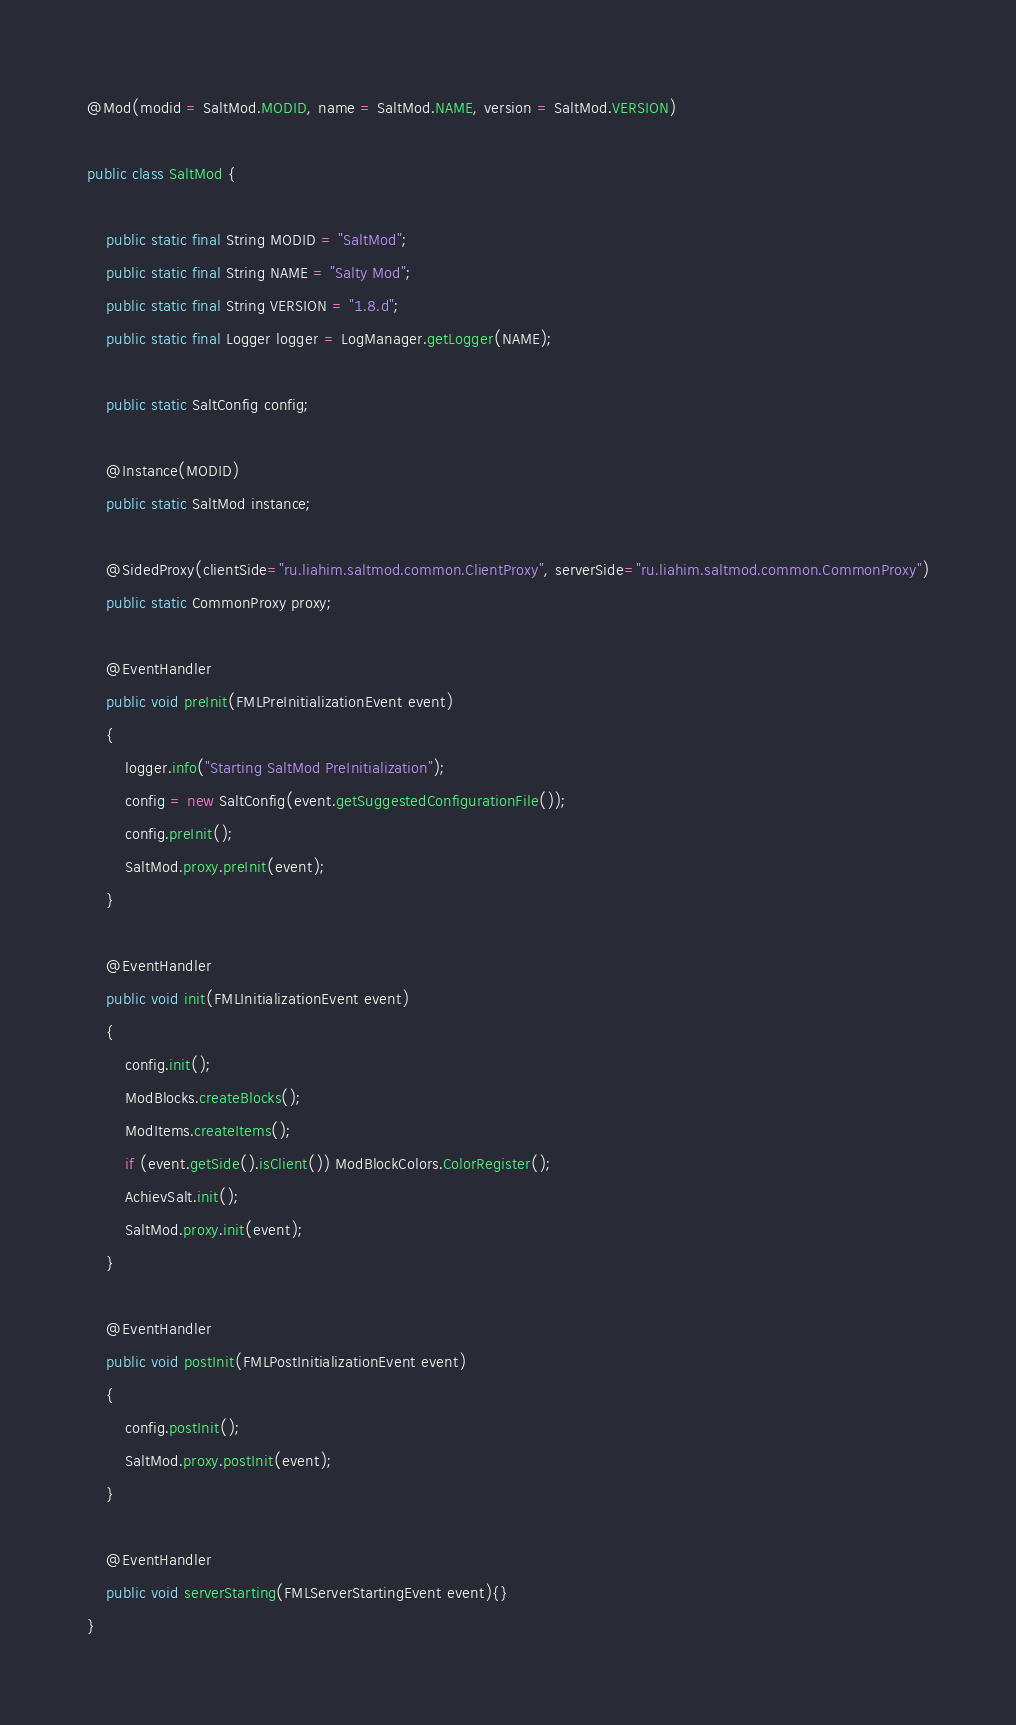Convert code to text. <code><loc_0><loc_0><loc_500><loc_500><_Java_>@Mod(modid = SaltMod.MODID, name = SaltMod.NAME, version = SaltMod.VERSION)

public class SaltMod {

    public static final String MODID = "SaltMod";
    public static final String NAME = "Salty Mod";
    public static final String VERSION = "1.8.d";
	public static final Logger logger = LogManager.getLogger(NAME);
    
	public static SaltConfig config;
	
    @Instance(MODID)
    public static SaltMod instance;
    
	@SidedProxy(clientSide="ru.liahim.saltmod.common.ClientProxy", serverSide="ru.liahim.saltmod.common.CommonProxy")
	public static CommonProxy proxy;

	@EventHandler
    public void preInit(FMLPreInitializationEvent event)
	{
		logger.info("Starting SaltMod PreInitialization");
        config = new SaltConfig(event.getSuggestedConfigurationFile());
        config.preInit();
	    SaltMod.proxy.preInit(event);
	}
	
    @EventHandler
    public void init(FMLInitializationEvent event)
    {
    	config.init();
	    ModBlocks.createBlocks();
        ModItems.createItems();
        if (event.getSide().isClient()) ModBlockColors.ColorRegister();
        AchievSalt.init();
    	SaltMod.proxy.init(event);
    }
 
    @EventHandler
    public void postInit(FMLPostInitializationEvent event)
    {
    	config.postInit();
    	SaltMod.proxy.postInit(event);
    }
 
    @EventHandler
    public void serverStarting(FMLServerStartingEvent event){}
}</code> 